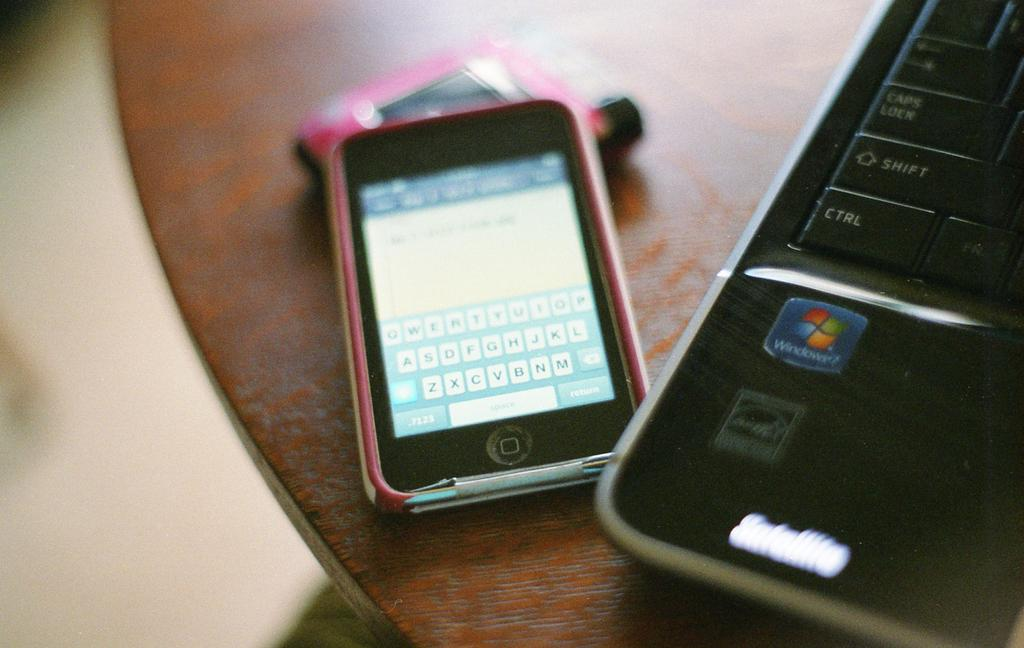<image>
Share a concise interpretation of the image provided. A pink and black iPhone sits beside a Windows Satellite laptop. 